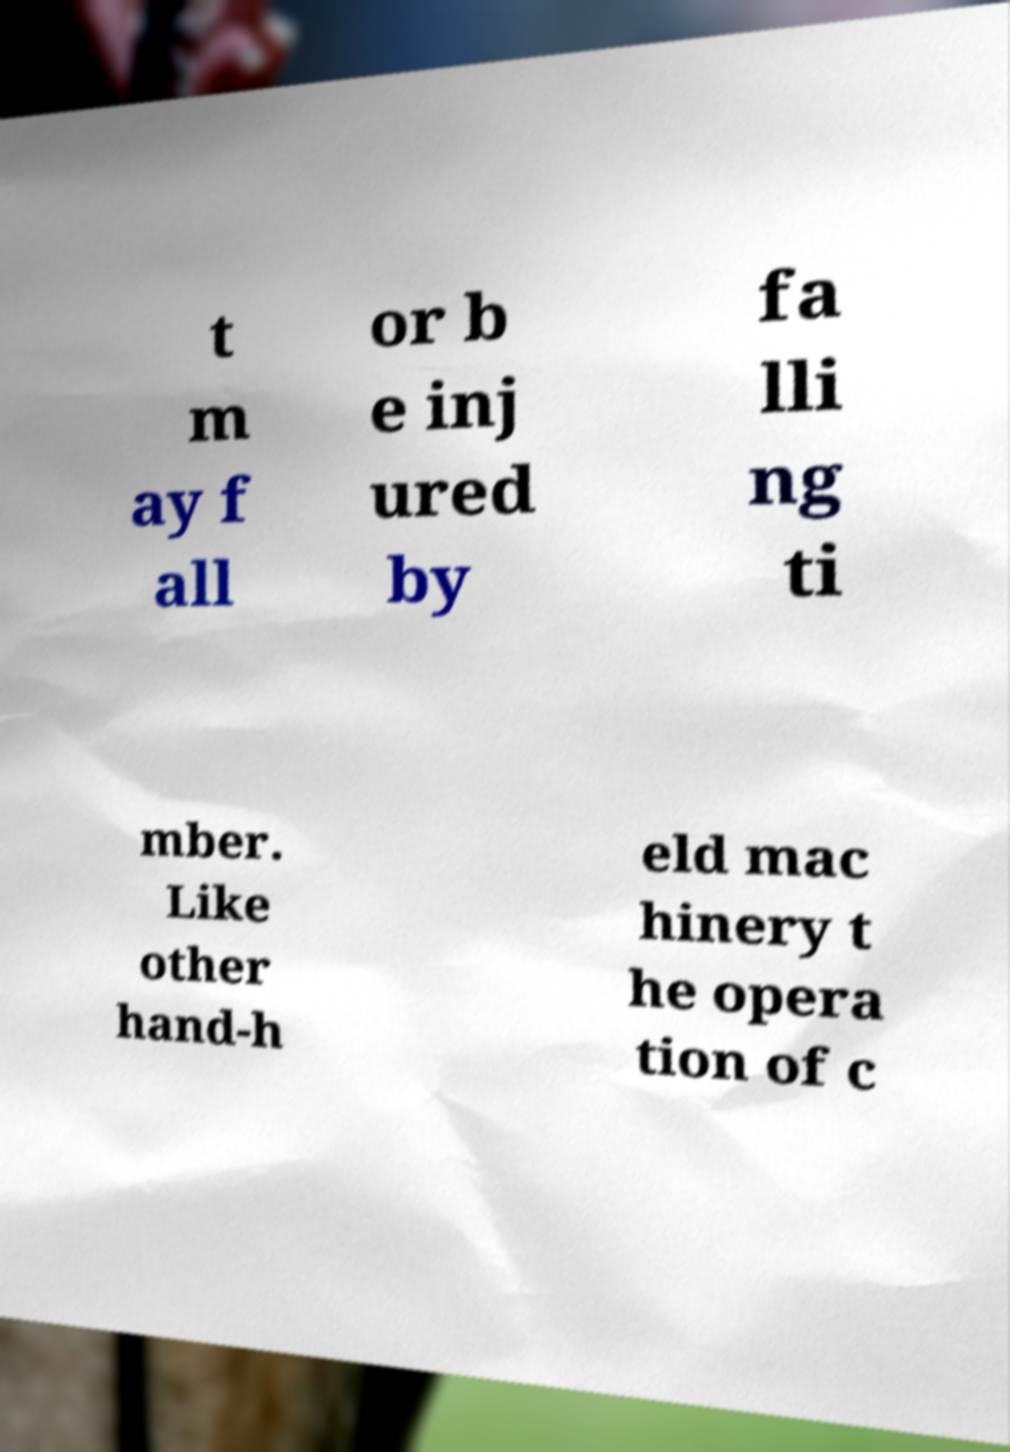What messages or text are displayed in this image? I need them in a readable, typed format. t m ay f all or b e inj ured by fa lli ng ti mber. Like other hand-h eld mac hinery t he opera tion of c 